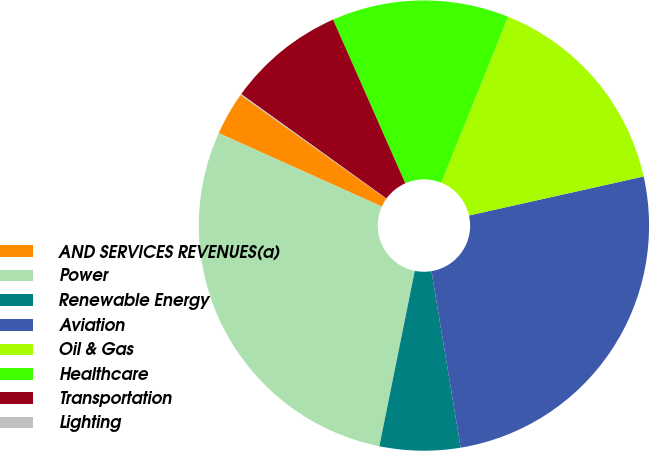<chart> <loc_0><loc_0><loc_500><loc_500><pie_chart><fcel>AND SERVICES REVENUES(a)<fcel>Power<fcel>Renewable Energy<fcel>Aviation<fcel>Oil & Gas<fcel>Healthcare<fcel>Transportation<fcel>Lighting<nl><fcel>3.11%<fcel>28.56%<fcel>5.78%<fcel>25.89%<fcel>15.4%<fcel>12.71%<fcel>8.46%<fcel>0.08%<nl></chart> 